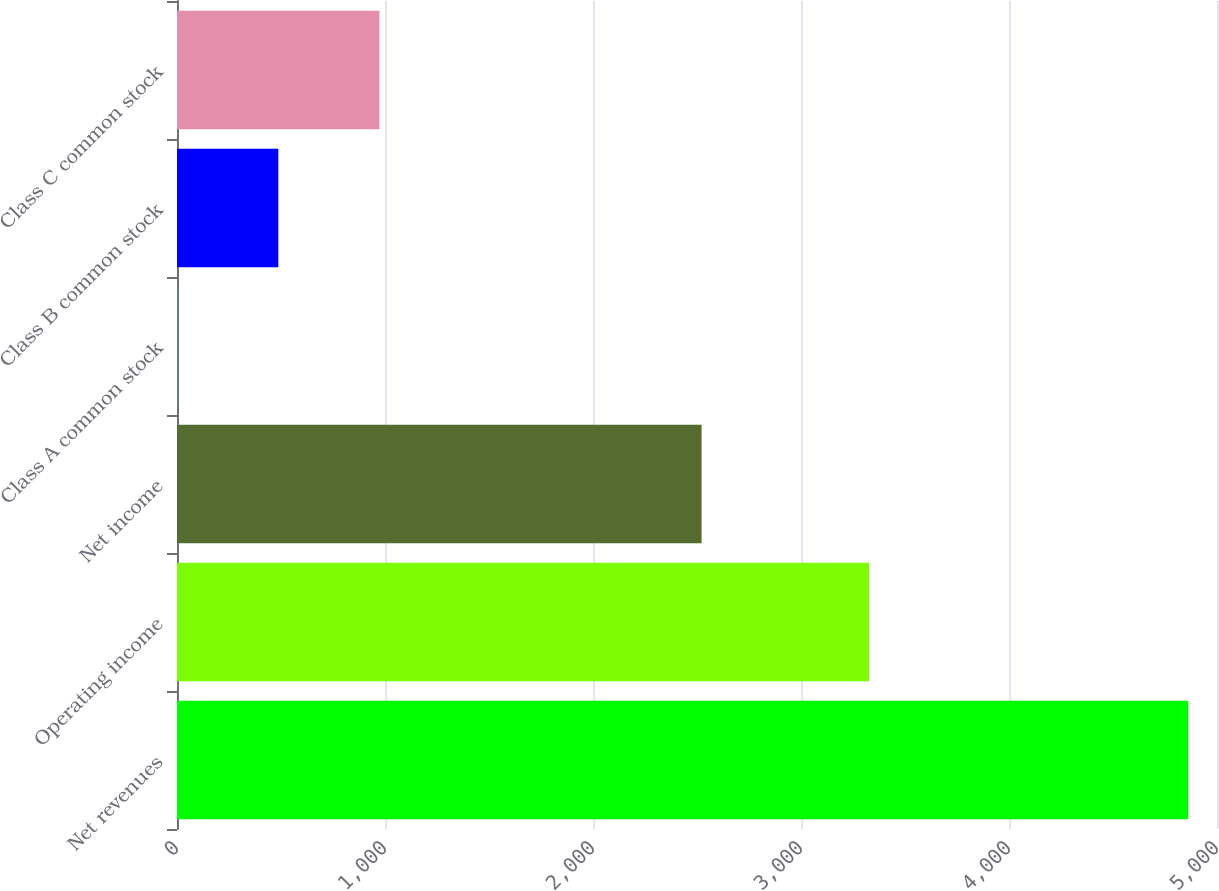<chart> <loc_0><loc_0><loc_500><loc_500><bar_chart><fcel>Net revenues<fcel>Operating income<fcel>Net income<fcel>Class A common stock<fcel>Class B common stock<fcel>Class C common stock<nl><fcel>4862<fcel>3327<fcel>2522<fcel>1.07<fcel>487.16<fcel>973.25<nl></chart> 